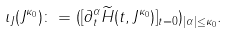<formula> <loc_0><loc_0><loc_500><loc_500>\iota _ { J } ( J ^ { \kappa _ { 0 } } ) \colon = ( [ \partial _ { t } ^ { \alpha } \widetilde { H } ( t , J ^ { \kappa _ { 0 } } ) ] _ { t = 0 } ) _ { | \alpha | \leq \kappa _ { 0 } } .</formula> 